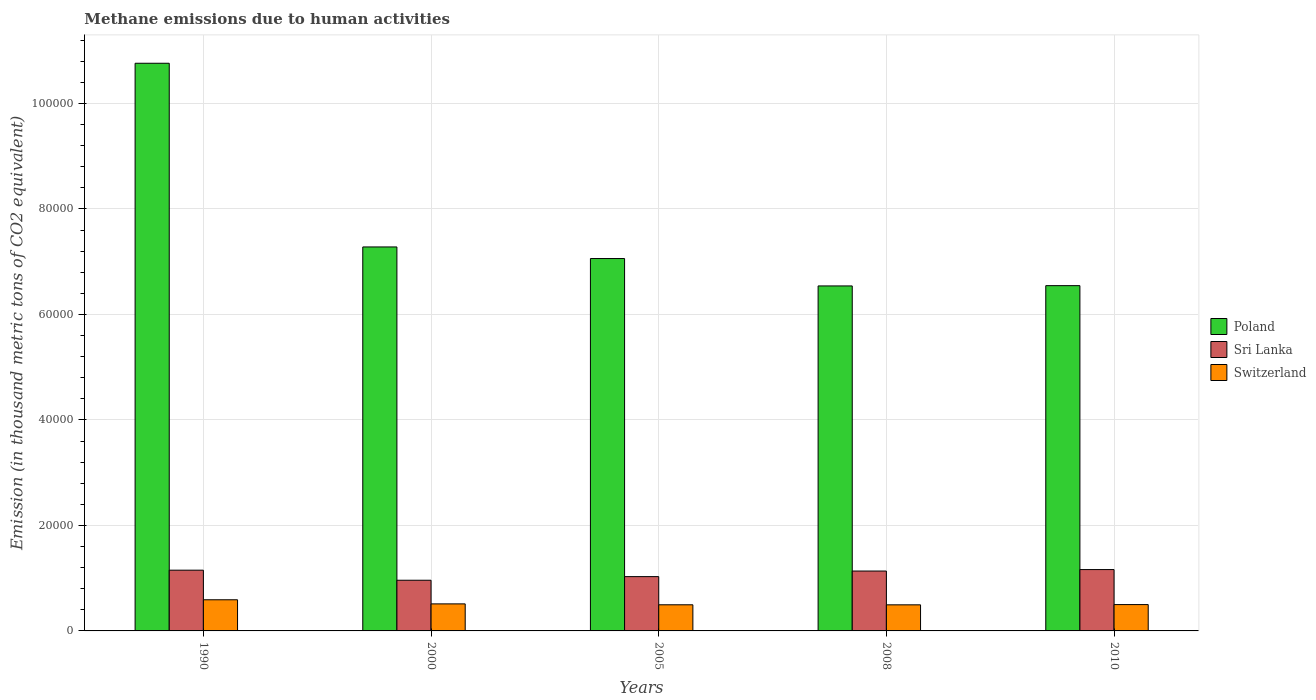How many different coloured bars are there?
Your response must be concise. 3. Are the number of bars on each tick of the X-axis equal?
Give a very brief answer. Yes. How many bars are there on the 1st tick from the left?
Provide a short and direct response. 3. What is the amount of methane emitted in Sri Lanka in 1990?
Your answer should be very brief. 1.15e+04. Across all years, what is the maximum amount of methane emitted in Sri Lanka?
Make the answer very short. 1.16e+04. Across all years, what is the minimum amount of methane emitted in Sri Lanka?
Keep it short and to the point. 9607.2. In which year was the amount of methane emitted in Poland minimum?
Your answer should be compact. 2008. What is the total amount of methane emitted in Poland in the graph?
Offer a very short reply. 3.82e+05. What is the difference between the amount of methane emitted in Switzerland in 1990 and that in 2005?
Make the answer very short. 951.4. What is the difference between the amount of methane emitted in Switzerland in 2010 and the amount of methane emitted in Sri Lanka in 2005?
Your response must be concise. -5302.1. What is the average amount of methane emitted in Sri Lanka per year?
Ensure brevity in your answer.  1.09e+04. In the year 2010, what is the difference between the amount of methane emitted in Switzerland and amount of methane emitted in Poland?
Your response must be concise. -6.05e+04. In how many years, is the amount of methane emitted in Sri Lanka greater than 96000 thousand metric tons?
Provide a succinct answer. 0. What is the ratio of the amount of methane emitted in Sri Lanka in 1990 to that in 2010?
Your answer should be very brief. 0.99. Is the amount of methane emitted in Switzerland in 1990 less than that in 2005?
Offer a terse response. No. What is the difference between the highest and the second highest amount of methane emitted in Poland?
Give a very brief answer. 3.48e+04. What is the difference between the highest and the lowest amount of methane emitted in Poland?
Provide a succinct answer. 4.22e+04. What does the 3rd bar from the left in 2008 represents?
Your response must be concise. Switzerland. What does the 2nd bar from the right in 2008 represents?
Offer a terse response. Sri Lanka. How many bars are there?
Provide a short and direct response. 15. Are all the bars in the graph horizontal?
Give a very brief answer. No. How many years are there in the graph?
Provide a short and direct response. 5. What is the difference between two consecutive major ticks on the Y-axis?
Keep it short and to the point. 2.00e+04. Are the values on the major ticks of Y-axis written in scientific E-notation?
Ensure brevity in your answer.  No. Does the graph contain any zero values?
Make the answer very short. No. Does the graph contain grids?
Provide a short and direct response. Yes. What is the title of the graph?
Your answer should be very brief. Methane emissions due to human activities. What is the label or title of the Y-axis?
Make the answer very short. Emission (in thousand metric tons of CO2 equivalent). What is the Emission (in thousand metric tons of CO2 equivalent) in Poland in 1990?
Keep it short and to the point. 1.08e+05. What is the Emission (in thousand metric tons of CO2 equivalent) of Sri Lanka in 1990?
Offer a very short reply. 1.15e+04. What is the Emission (in thousand metric tons of CO2 equivalent) in Switzerland in 1990?
Make the answer very short. 5904.8. What is the Emission (in thousand metric tons of CO2 equivalent) in Poland in 2000?
Your response must be concise. 7.28e+04. What is the Emission (in thousand metric tons of CO2 equivalent) in Sri Lanka in 2000?
Your response must be concise. 9607.2. What is the Emission (in thousand metric tons of CO2 equivalent) in Switzerland in 2000?
Provide a succinct answer. 5126.2. What is the Emission (in thousand metric tons of CO2 equivalent) in Poland in 2005?
Give a very brief answer. 7.06e+04. What is the Emission (in thousand metric tons of CO2 equivalent) of Sri Lanka in 2005?
Keep it short and to the point. 1.03e+04. What is the Emission (in thousand metric tons of CO2 equivalent) of Switzerland in 2005?
Your answer should be very brief. 4953.4. What is the Emission (in thousand metric tons of CO2 equivalent) of Poland in 2008?
Your answer should be compact. 6.54e+04. What is the Emission (in thousand metric tons of CO2 equivalent) of Sri Lanka in 2008?
Provide a succinct answer. 1.14e+04. What is the Emission (in thousand metric tons of CO2 equivalent) of Switzerland in 2008?
Your answer should be compact. 4946.1. What is the Emission (in thousand metric tons of CO2 equivalent) in Poland in 2010?
Provide a succinct answer. 6.55e+04. What is the Emission (in thousand metric tons of CO2 equivalent) of Sri Lanka in 2010?
Offer a terse response. 1.16e+04. What is the Emission (in thousand metric tons of CO2 equivalent) in Switzerland in 2010?
Your answer should be very brief. 4992.4. Across all years, what is the maximum Emission (in thousand metric tons of CO2 equivalent) in Poland?
Your answer should be very brief. 1.08e+05. Across all years, what is the maximum Emission (in thousand metric tons of CO2 equivalent) in Sri Lanka?
Make the answer very short. 1.16e+04. Across all years, what is the maximum Emission (in thousand metric tons of CO2 equivalent) of Switzerland?
Your answer should be compact. 5904.8. Across all years, what is the minimum Emission (in thousand metric tons of CO2 equivalent) in Poland?
Offer a terse response. 6.54e+04. Across all years, what is the minimum Emission (in thousand metric tons of CO2 equivalent) in Sri Lanka?
Offer a very short reply. 9607.2. Across all years, what is the minimum Emission (in thousand metric tons of CO2 equivalent) in Switzerland?
Provide a short and direct response. 4946.1. What is the total Emission (in thousand metric tons of CO2 equivalent) in Poland in the graph?
Your response must be concise. 3.82e+05. What is the total Emission (in thousand metric tons of CO2 equivalent) of Sri Lanka in the graph?
Make the answer very short. 5.44e+04. What is the total Emission (in thousand metric tons of CO2 equivalent) in Switzerland in the graph?
Offer a terse response. 2.59e+04. What is the difference between the Emission (in thousand metric tons of CO2 equivalent) of Poland in 1990 and that in 2000?
Offer a very short reply. 3.48e+04. What is the difference between the Emission (in thousand metric tons of CO2 equivalent) in Sri Lanka in 1990 and that in 2000?
Give a very brief answer. 1907. What is the difference between the Emission (in thousand metric tons of CO2 equivalent) of Switzerland in 1990 and that in 2000?
Provide a short and direct response. 778.6. What is the difference between the Emission (in thousand metric tons of CO2 equivalent) in Poland in 1990 and that in 2005?
Your answer should be very brief. 3.70e+04. What is the difference between the Emission (in thousand metric tons of CO2 equivalent) in Sri Lanka in 1990 and that in 2005?
Your answer should be compact. 1219.7. What is the difference between the Emission (in thousand metric tons of CO2 equivalent) in Switzerland in 1990 and that in 2005?
Provide a short and direct response. 951.4. What is the difference between the Emission (in thousand metric tons of CO2 equivalent) of Poland in 1990 and that in 2008?
Offer a terse response. 4.22e+04. What is the difference between the Emission (in thousand metric tons of CO2 equivalent) in Sri Lanka in 1990 and that in 2008?
Your answer should be very brief. 161. What is the difference between the Emission (in thousand metric tons of CO2 equivalent) in Switzerland in 1990 and that in 2008?
Your response must be concise. 958.7. What is the difference between the Emission (in thousand metric tons of CO2 equivalent) of Poland in 1990 and that in 2010?
Provide a short and direct response. 4.22e+04. What is the difference between the Emission (in thousand metric tons of CO2 equivalent) of Sri Lanka in 1990 and that in 2010?
Your answer should be compact. -116.7. What is the difference between the Emission (in thousand metric tons of CO2 equivalent) of Switzerland in 1990 and that in 2010?
Your response must be concise. 912.4. What is the difference between the Emission (in thousand metric tons of CO2 equivalent) in Poland in 2000 and that in 2005?
Ensure brevity in your answer.  2197.9. What is the difference between the Emission (in thousand metric tons of CO2 equivalent) of Sri Lanka in 2000 and that in 2005?
Your response must be concise. -687.3. What is the difference between the Emission (in thousand metric tons of CO2 equivalent) of Switzerland in 2000 and that in 2005?
Give a very brief answer. 172.8. What is the difference between the Emission (in thousand metric tons of CO2 equivalent) of Poland in 2000 and that in 2008?
Ensure brevity in your answer.  7391.3. What is the difference between the Emission (in thousand metric tons of CO2 equivalent) in Sri Lanka in 2000 and that in 2008?
Your answer should be very brief. -1746. What is the difference between the Emission (in thousand metric tons of CO2 equivalent) in Switzerland in 2000 and that in 2008?
Make the answer very short. 180.1. What is the difference between the Emission (in thousand metric tons of CO2 equivalent) in Poland in 2000 and that in 2010?
Offer a terse response. 7338.4. What is the difference between the Emission (in thousand metric tons of CO2 equivalent) in Sri Lanka in 2000 and that in 2010?
Offer a terse response. -2023.7. What is the difference between the Emission (in thousand metric tons of CO2 equivalent) in Switzerland in 2000 and that in 2010?
Provide a succinct answer. 133.8. What is the difference between the Emission (in thousand metric tons of CO2 equivalent) in Poland in 2005 and that in 2008?
Ensure brevity in your answer.  5193.4. What is the difference between the Emission (in thousand metric tons of CO2 equivalent) of Sri Lanka in 2005 and that in 2008?
Your answer should be compact. -1058.7. What is the difference between the Emission (in thousand metric tons of CO2 equivalent) of Poland in 2005 and that in 2010?
Provide a short and direct response. 5140.5. What is the difference between the Emission (in thousand metric tons of CO2 equivalent) in Sri Lanka in 2005 and that in 2010?
Give a very brief answer. -1336.4. What is the difference between the Emission (in thousand metric tons of CO2 equivalent) of Switzerland in 2005 and that in 2010?
Your response must be concise. -39. What is the difference between the Emission (in thousand metric tons of CO2 equivalent) in Poland in 2008 and that in 2010?
Provide a succinct answer. -52.9. What is the difference between the Emission (in thousand metric tons of CO2 equivalent) in Sri Lanka in 2008 and that in 2010?
Give a very brief answer. -277.7. What is the difference between the Emission (in thousand metric tons of CO2 equivalent) of Switzerland in 2008 and that in 2010?
Offer a very short reply. -46.3. What is the difference between the Emission (in thousand metric tons of CO2 equivalent) in Poland in 1990 and the Emission (in thousand metric tons of CO2 equivalent) in Sri Lanka in 2000?
Your response must be concise. 9.80e+04. What is the difference between the Emission (in thousand metric tons of CO2 equivalent) of Poland in 1990 and the Emission (in thousand metric tons of CO2 equivalent) of Switzerland in 2000?
Make the answer very short. 1.02e+05. What is the difference between the Emission (in thousand metric tons of CO2 equivalent) of Sri Lanka in 1990 and the Emission (in thousand metric tons of CO2 equivalent) of Switzerland in 2000?
Provide a succinct answer. 6388. What is the difference between the Emission (in thousand metric tons of CO2 equivalent) in Poland in 1990 and the Emission (in thousand metric tons of CO2 equivalent) in Sri Lanka in 2005?
Your answer should be compact. 9.73e+04. What is the difference between the Emission (in thousand metric tons of CO2 equivalent) in Poland in 1990 and the Emission (in thousand metric tons of CO2 equivalent) in Switzerland in 2005?
Give a very brief answer. 1.03e+05. What is the difference between the Emission (in thousand metric tons of CO2 equivalent) in Sri Lanka in 1990 and the Emission (in thousand metric tons of CO2 equivalent) in Switzerland in 2005?
Offer a very short reply. 6560.8. What is the difference between the Emission (in thousand metric tons of CO2 equivalent) in Poland in 1990 and the Emission (in thousand metric tons of CO2 equivalent) in Sri Lanka in 2008?
Keep it short and to the point. 9.63e+04. What is the difference between the Emission (in thousand metric tons of CO2 equivalent) in Poland in 1990 and the Emission (in thousand metric tons of CO2 equivalent) in Switzerland in 2008?
Your answer should be compact. 1.03e+05. What is the difference between the Emission (in thousand metric tons of CO2 equivalent) of Sri Lanka in 1990 and the Emission (in thousand metric tons of CO2 equivalent) of Switzerland in 2008?
Make the answer very short. 6568.1. What is the difference between the Emission (in thousand metric tons of CO2 equivalent) of Poland in 1990 and the Emission (in thousand metric tons of CO2 equivalent) of Sri Lanka in 2010?
Offer a terse response. 9.60e+04. What is the difference between the Emission (in thousand metric tons of CO2 equivalent) of Poland in 1990 and the Emission (in thousand metric tons of CO2 equivalent) of Switzerland in 2010?
Keep it short and to the point. 1.03e+05. What is the difference between the Emission (in thousand metric tons of CO2 equivalent) in Sri Lanka in 1990 and the Emission (in thousand metric tons of CO2 equivalent) in Switzerland in 2010?
Offer a terse response. 6521.8. What is the difference between the Emission (in thousand metric tons of CO2 equivalent) in Poland in 2000 and the Emission (in thousand metric tons of CO2 equivalent) in Sri Lanka in 2005?
Provide a succinct answer. 6.25e+04. What is the difference between the Emission (in thousand metric tons of CO2 equivalent) in Poland in 2000 and the Emission (in thousand metric tons of CO2 equivalent) in Switzerland in 2005?
Keep it short and to the point. 6.78e+04. What is the difference between the Emission (in thousand metric tons of CO2 equivalent) of Sri Lanka in 2000 and the Emission (in thousand metric tons of CO2 equivalent) of Switzerland in 2005?
Ensure brevity in your answer.  4653.8. What is the difference between the Emission (in thousand metric tons of CO2 equivalent) of Poland in 2000 and the Emission (in thousand metric tons of CO2 equivalent) of Sri Lanka in 2008?
Your response must be concise. 6.14e+04. What is the difference between the Emission (in thousand metric tons of CO2 equivalent) in Poland in 2000 and the Emission (in thousand metric tons of CO2 equivalent) in Switzerland in 2008?
Ensure brevity in your answer.  6.78e+04. What is the difference between the Emission (in thousand metric tons of CO2 equivalent) in Sri Lanka in 2000 and the Emission (in thousand metric tons of CO2 equivalent) in Switzerland in 2008?
Provide a short and direct response. 4661.1. What is the difference between the Emission (in thousand metric tons of CO2 equivalent) of Poland in 2000 and the Emission (in thousand metric tons of CO2 equivalent) of Sri Lanka in 2010?
Your response must be concise. 6.12e+04. What is the difference between the Emission (in thousand metric tons of CO2 equivalent) in Poland in 2000 and the Emission (in thousand metric tons of CO2 equivalent) in Switzerland in 2010?
Ensure brevity in your answer.  6.78e+04. What is the difference between the Emission (in thousand metric tons of CO2 equivalent) of Sri Lanka in 2000 and the Emission (in thousand metric tons of CO2 equivalent) of Switzerland in 2010?
Make the answer very short. 4614.8. What is the difference between the Emission (in thousand metric tons of CO2 equivalent) in Poland in 2005 and the Emission (in thousand metric tons of CO2 equivalent) in Sri Lanka in 2008?
Your answer should be compact. 5.92e+04. What is the difference between the Emission (in thousand metric tons of CO2 equivalent) of Poland in 2005 and the Emission (in thousand metric tons of CO2 equivalent) of Switzerland in 2008?
Provide a succinct answer. 6.56e+04. What is the difference between the Emission (in thousand metric tons of CO2 equivalent) in Sri Lanka in 2005 and the Emission (in thousand metric tons of CO2 equivalent) in Switzerland in 2008?
Offer a terse response. 5348.4. What is the difference between the Emission (in thousand metric tons of CO2 equivalent) in Poland in 2005 and the Emission (in thousand metric tons of CO2 equivalent) in Sri Lanka in 2010?
Your response must be concise. 5.90e+04. What is the difference between the Emission (in thousand metric tons of CO2 equivalent) of Poland in 2005 and the Emission (in thousand metric tons of CO2 equivalent) of Switzerland in 2010?
Offer a very short reply. 6.56e+04. What is the difference between the Emission (in thousand metric tons of CO2 equivalent) in Sri Lanka in 2005 and the Emission (in thousand metric tons of CO2 equivalent) in Switzerland in 2010?
Provide a succinct answer. 5302.1. What is the difference between the Emission (in thousand metric tons of CO2 equivalent) of Poland in 2008 and the Emission (in thousand metric tons of CO2 equivalent) of Sri Lanka in 2010?
Make the answer very short. 5.38e+04. What is the difference between the Emission (in thousand metric tons of CO2 equivalent) in Poland in 2008 and the Emission (in thousand metric tons of CO2 equivalent) in Switzerland in 2010?
Your answer should be very brief. 6.04e+04. What is the difference between the Emission (in thousand metric tons of CO2 equivalent) in Sri Lanka in 2008 and the Emission (in thousand metric tons of CO2 equivalent) in Switzerland in 2010?
Keep it short and to the point. 6360.8. What is the average Emission (in thousand metric tons of CO2 equivalent) in Poland per year?
Your response must be concise. 7.64e+04. What is the average Emission (in thousand metric tons of CO2 equivalent) of Sri Lanka per year?
Your answer should be compact. 1.09e+04. What is the average Emission (in thousand metric tons of CO2 equivalent) in Switzerland per year?
Keep it short and to the point. 5184.58. In the year 1990, what is the difference between the Emission (in thousand metric tons of CO2 equivalent) in Poland and Emission (in thousand metric tons of CO2 equivalent) in Sri Lanka?
Your answer should be very brief. 9.61e+04. In the year 1990, what is the difference between the Emission (in thousand metric tons of CO2 equivalent) of Poland and Emission (in thousand metric tons of CO2 equivalent) of Switzerland?
Offer a very short reply. 1.02e+05. In the year 1990, what is the difference between the Emission (in thousand metric tons of CO2 equivalent) in Sri Lanka and Emission (in thousand metric tons of CO2 equivalent) in Switzerland?
Ensure brevity in your answer.  5609.4. In the year 2000, what is the difference between the Emission (in thousand metric tons of CO2 equivalent) in Poland and Emission (in thousand metric tons of CO2 equivalent) in Sri Lanka?
Offer a terse response. 6.32e+04. In the year 2000, what is the difference between the Emission (in thousand metric tons of CO2 equivalent) in Poland and Emission (in thousand metric tons of CO2 equivalent) in Switzerland?
Your answer should be very brief. 6.77e+04. In the year 2000, what is the difference between the Emission (in thousand metric tons of CO2 equivalent) of Sri Lanka and Emission (in thousand metric tons of CO2 equivalent) of Switzerland?
Make the answer very short. 4481. In the year 2005, what is the difference between the Emission (in thousand metric tons of CO2 equivalent) in Poland and Emission (in thousand metric tons of CO2 equivalent) in Sri Lanka?
Keep it short and to the point. 6.03e+04. In the year 2005, what is the difference between the Emission (in thousand metric tons of CO2 equivalent) of Poland and Emission (in thousand metric tons of CO2 equivalent) of Switzerland?
Your answer should be very brief. 6.56e+04. In the year 2005, what is the difference between the Emission (in thousand metric tons of CO2 equivalent) in Sri Lanka and Emission (in thousand metric tons of CO2 equivalent) in Switzerland?
Your answer should be very brief. 5341.1. In the year 2008, what is the difference between the Emission (in thousand metric tons of CO2 equivalent) in Poland and Emission (in thousand metric tons of CO2 equivalent) in Sri Lanka?
Your answer should be very brief. 5.40e+04. In the year 2008, what is the difference between the Emission (in thousand metric tons of CO2 equivalent) of Poland and Emission (in thousand metric tons of CO2 equivalent) of Switzerland?
Your response must be concise. 6.05e+04. In the year 2008, what is the difference between the Emission (in thousand metric tons of CO2 equivalent) of Sri Lanka and Emission (in thousand metric tons of CO2 equivalent) of Switzerland?
Give a very brief answer. 6407.1. In the year 2010, what is the difference between the Emission (in thousand metric tons of CO2 equivalent) of Poland and Emission (in thousand metric tons of CO2 equivalent) of Sri Lanka?
Provide a short and direct response. 5.38e+04. In the year 2010, what is the difference between the Emission (in thousand metric tons of CO2 equivalent) in Poland and Emission (in thousand metric tons of CO2 equivalent) in Switzerland?
Provide a succinct answer. 6.05e+04. In the year 2010, what is the difference between the Emission (in thousand metric tons of CO2 equivalent) of Sri Lanka and Emission (in thousand metric tons of CO2 equivalent) of Switzerland?
Offer a very short reply. 6638.5. What is the ratio of the Emission (in thousand metric tons of CO2 equivalent) in Poland in 1990 to that in 2000?
Make the answer very short. 1.48. What is the ratio of the Emission (in thousand metric tons of CO2 equivalent) of Sri Lanka in 1990 to that in 2000?
Ensure brevity in your answer.  1.2. What is the ratio of the Emission (in thousand metric tons of CO2 equivalent) in Switzerland in 1990 to that in 2000?
Your answer should be compact. 1.15. What is the ratio of the Emission (in thousand metric tons of CO2 equivalent) in Poland in 1990 to that in 2005?
Offer a very short reply. 1.52. What is the ratio of the Emission (in thousand metric tons of CO2 equivalent) of Sri Lanka in 1990 to that in 2005?
Offer a very short reply. 1.12. What is the ratio of the Emission (in thousand metric tons of CO2 equivalent) of Switzerland in 1990 to that in 2005?
Offer a very short reply. 1.19. What is the ratio of the Emission (in thousand metric tons of CO2 equivalent) in Poland in 1990 to that in 2008?
Your answer should be compact. 1.65. What is the ratio of the Emission (in thousand metric tons of CO2 equivalent) of Sri Lanka in 1990 to that in 2008?
Give a very brief answer. 1.01. What is the ratio of the Emission (in thousand metric tons of CO2 equivalent) in Switzerland in 1990 to that in 2008?
Your answer should be very brief. 1.19. What is the ratio of the Emission (in thousand metric tons of CO2 equivalent) of Poland in 1990 to that in 2010?
Keep it short and to the point. 1.64. What is the ratio of the Emission (in thousand metric tons of CO2 equivalent) of Sri Lanka in 1990 to that in 2010?
Ensure brevity in your answer.  0.99. What is the ratio of the Emission (in thousand metric tons of CO2 equivalent) of Switzerland in 1990 to that in 2010?
Your response must be concise. 1.18. What is the ratio of the Emission (in thousand metric tons of CO2 equivalent) in Poland in 2000 to that in 2005?
Your response must be concise. 1.03. What is the ratio of the Emission (in thousand metric tons of CO2 equivalent) of Sri Lanka in 2000 to that in 2005?
Offer a very short reply. 0.93. What is the ratio of the Emission (in thousand metric tons of CO2 equivalent) in Switzerland in 2000 to that in 2005?
Provide a succinct answer. 1.03. What is the ratio of the Emission (in thousand metric tons of CO2 equivalent) of Poland in 2000 to that in 2008?
Provide a short and direct response. 1.11. What is the ratio of the Emission (in thousand metric tons of CO2 equivalent) in Sri Lanka in 2000 to that in 2008?
Provide a succinct answer. 0.85. What is the ratio of the Emission (in thousand metric tons of CO2 equivalent) in Switzerland in 2000 to that in 2008?
Ensure brevity in your answer.  1.04. What is the ratio of the Emission (in thousand metric tons of CO2 equivalent) in Poland in 2000 to that in 2010?
Make the answer very short. 1.11. What is the ratio of the Emission (in thousand metric tons of CO2 equivalent) in Sri Lanka in 2000 to that in 2010?
Offer a very short reply. 0.83. What is the ratio of the Emission (in thousand metric tons of CO2 equivalent) of Switzerland in 2000 to that in 2010?
Ensure brevity in your answer.  1.03. What is the ratio of the Emission (in thousand metric tons of CO2 equivalent) of Poland in 2005 to that in 2008?
Keep it short and to the point. 1.08. What is the ratio of the Emission (in thousand metric tons of CO2 equivalent) of Sri Lanka in 2005 to that in 2008?
Ensure brevity in your answer.  0.91. What is the ratio of the Emission (in thousand metric tons of CO2 equivalent) of Poland in 2005 to that in 2010?
Offer a very short reply. 1.08. What is the ratio of the Emission (in thousand metric tons of CO2 equivalent) in Sri Lanka in 2005 to that in 2010?
Your response must be concise. 0.89. What is the ratio of the Emission (in thousand metric tons of CO2 equivalent) of Poland in 2008 to that in 2010?
Your answer should be very brief. 1. What is the ratio of the Emission (in thousand metric tons of CO2 equivalent) of Sri Lanka in 2008 to that in 2010?
Provide a short and direct response. 0.98. What is the difference between the highest and the second highest Emission (in thousand metric tons of CO2 equivalent) in Poland?
Your answer should be compact. 3.48e+04. What is the difference between the highest and the second highest Emission (in thousand metric tons of CO2 equivalent) in Sri Lanka?
Provide a short and direct response. 116.7. What is the difference between the highest and the second highest Emission (in thousand metric tons of CO2 equivalent) of Switzerland?
Provide a short and direct response. 778.6. What is the difference between the highest and the lowest Emission (in thousand metric tons of CO2 equivalent) in Poland?
Give a very brief answer. 4.22e+04. What is the difference between the highest and the lowest Emission (in thousand metric tons of CO2 equivalent) of Sri Lanka?
Ensure brevity in your answer.  2023.7. What is the difference between the highest and the lowest Emission (in thousand metric tons of CO2 equivalent) of Switzerland?
Ensure brevity in your answer.  958.7. 